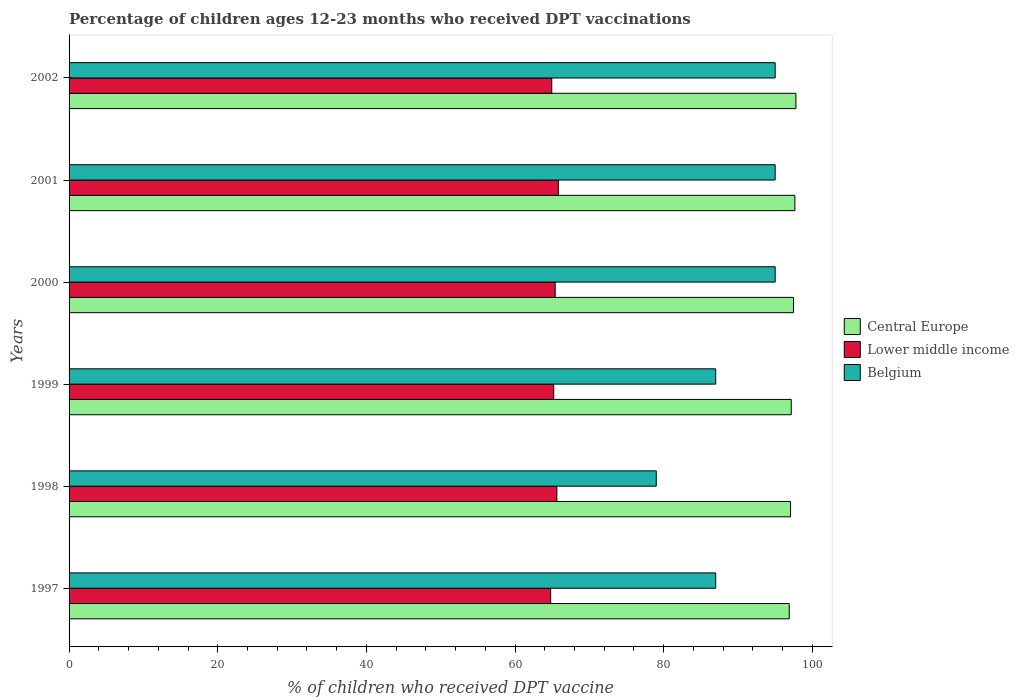How many different coloured bars are there?
Keep it short and to the point. 3. How many groups of bars are there?
Your response must be concise. 6. Are the number of bars per tick equal to the number of legend labels?
Your answer should be compact. Yes. What is the label of the 6th group of bars from the top?
Keep it short and to the point. 1997. What is the percentage of children who received DPT vaccination in Central Europe in 2001?
Your response must be concise. 97.65. Across all years, what is the maximum percentage of children who received DPT vaccination in Central Europe?
Your answer should be compact. 97.79. Across all years, what is the minimum percentage of children who received DPT vaccination in Central Europe?
Your answer should be compact. 96.89. What is the total percentage of children who received DPT vaccination in Lower middle income in the graph?
Give a very brief answer. 391.79. What is the difference between the percentage of children who received DPT vaccination in Belgium in 2000 and that in 2001?
Make the answer very short. 0. What is the difference between the percentage of children who received DPT vaccination in Central Europe in 1998 and the percentage of children who received DPT vaccination in Belgium in 1997?
Make the answer very short. 10.07. What is the average percentage of children who received DPT vaccination in Central Europe per year?
Give a very brief answer. 97.34. In the year 2000, what is the difference between the percentage of children who received DPT vaccination in Central Europe and percentage of children who received DPT vaccination in Lower middle income?
Provide a short and direct response. 32.06. In how many years, is the percentage of children who received DPT vaccination in Belgium greater than 44 %?
Keep it short and to the point. 6. What is the ratio of the percentage of children who received DPT vaccination in Belgium in 1998 to that in 2000?
Your answer should be compact. 0.83. What is the difference between the highest and the second highest percentage of children who received DPT vaccination in Lower middle income?
Provide a short and direct response. 0.19. What is the difference between the highest and the lowest percentage of children who received DPT vaccination in Belgium?
Provide a succinct answer. 16. In how many years, is the percentage of children who received DPT vaccination in Central Europe greater than the average percentage of children who received DPT vaccination in Central Europe taken over all years?
Offer a very short reply. 3. What does the 3rd bar from the top in 1998 represents?
Give a very brief answer. Central Europe. What does the 2nd bar from the bottom in 1997 represents?
Your answer should be compact. Lower middle income. Is it the case that in every year, the sum of the percentage of children who received DPT vaccination in Belgium and percentage of children who received DPT vaccination in Central Europe is greater than the percentage of children who received DPT vaccination in Lower middle income?
Provide a succinct answer. Yes. How many years are there in the graph?
Offer a very short reply. 6. Does the graph contain grids?
Keep it short and to the point. No. Where does the legend appear in the graph?
Keep it short and to the point. Center right. How are the legend labels stacked?
Provide a succinct answer. Vertical. What is the title of the graph?
Your answer should be compact. Percentage of children ages 12-23 months who received DPT vaccinations. What is the label or title of the X-axis?
Offer a very short reply. % of children who received DPT vaccine. What is the % of children who received DPT vaccine in Central Europe in 1997?
Make the answer very short. 96.89. What is the % of children who received DPT vaccine in Lower middle income in 1997?
Keep it short and to the point. 64.79. What is the % of children who received DPT vaccine in Belgium in 1997?
Ensure brevity in your answer.  87. What is the % of children who received DPT vaccine in Central Europe in 1998?
Offer a very short reply. 97.07. What is the % of children who received DPT vaccine of Lower middle income in 1998?
Provide a short and direct response. 65.63. What is the % of children who received DPT vaccine of Belgium in 1998?
Provide a succinct answer. 79. What is the % of children who received DPT vaccine in Central Europe in 1999?
Make the answer very short. 97.16. What is the % of children who received DPT vaccine of Lower middle income in 1999?
Keep it short and to the point. 65.2. What is the % of children who received DPT vaccine of Belgium in 1999?
Keep it short and to the point. 87. What is the % of children who received DPT vaccine in Central Europe in 2000?
Keep it short and to the point. 97.46. What is the % of children who received DPT vaccine of Lower middle income in 2000?
Provide a short and direct response. 65.4. What is the % of children who received DPT vaccine of Belgium in 2000?
Offer a very short reply. 95. What is the % of children who received DPT vaccine of Central Europe in 2001?
Offer a very short reply. 97.65. What is the % of children who received DPT vaccine of Lower middle income in 2001?
Give a very brief answer. 65.82. What is the % of children who received DPT vaccine of Belgium in 2001?
Give a very brief answer. 95. What is the % of children who received DPT vaccine in Central Europe in 2002?
Provide a succinct answer. 97.79. What is the % of children who received DPT vaccine in Lower middle income in 2002?
Keep it short and to the point. 64.94. Across all years, what is the maximum % of children who received DPT vaccine of Central Europe?
Offer a terse response. 97.79. Across all years, what is the maximum % of children who received DPT vaccine in Lower middle income?
Offer a very short reply. 65.82. Across all years, what is the minimum % of children who received DPT vaccine of Central Europe?
Offer a terse response. 96.89. Across all years, what is the minimum % of children who received DPT vaccine in Lower middle income?
Give a very brief answer. 64.79. Across all years, what is the minimum % of children who received DPT vaccine in Belgium?
Give a very brief answer. 79. What is the total % of children who received DPT vaccine of Central Europe in the graph?
Offer a very short reply. 584.03. What is the total % of children who received DPT vaccine in Lower middle income in the graph?
Make the answer very short. 391.79. What is the total % of children who received DPT vaccine in Belgium in the graph?
Give a very brief answer. 538. What is the difference between the % of children who received DPT vaccine in Central Europe in 1997 and that in 1998?
Give a very brief answer. -0.18. What is the difference between the % of children who received DPT vaccine of Lower middle income in 1997 and that in 1998?
Your answer should be very brief. -0.84. What is the difference between the % of children who received DPT vaccine of Belgium in 1997 and that in 1998?
Make the answer very short. 8. What is the difference between the % of children who received DPT vaccine in Central Europe in 1997 and that in 1999?
Offer a very short reply. -0.27. What is the difference between the % of children who received DPT vaccine of Lower middle income in 1997 and that in 1999?
Your response must be concise. -0.41. What is the difference between the % of children who received DPT vaccine in Belgium in 1997 and that in 1999?
Your response must be concise. 0. What is the difference between the % of children who received DPT vaccine in Central Europe in 1997 and that in 2000?
Your answer should be compact. -0.57. What is the difference between the % of children who received DPT vaccine in Lower middle income in 1997 and that in 2000?
Your answer should be compact. -0.61. What is the difference between the % of children who received DPT vaccine of Central Europe in 1997 and that in 2001?
Your response must be concise. -0.76. What is the difference between the % of children who received DPT vaccine in Lower middle income in 1997 and that in 2001?
Keep it short and to the point. -1.03. What is the difference between the % of children who received DPT vaccine of Central Europe in 1997 and that in 2002?
Your answer should be very brief. -0.9. What is the difference between the % of children who received DPT vaccine of Lower middle income in 1997 and that in 2002?
Your answer should be compact. -0.15. What is the difference between the % of children who received DPT vaccine in Belgium in 1997 and that in 2002?
Provide a succinct answer. -8. What is the difference between the % of children who received DPT vaccine of Central Europe in 1998 and that in 1999?
Make the answer very short. -0.1. What is the difference between the % of children who received DPT vaccine in Lower middle income in 1998 and that in 1999?
Ensure brevity in your answer.  0.43. What is the difference between the % of children who received DPT vaccine of Belgium in 1998 and that in 1999?
Give a very brief answer. -8. What is the difference between the % of children who received DPT vaccine in Central Europe in 1998 and that in 2000?
Keep it short and to the point. -0.39. What is the difference between the % of children who received DPT vaccine in Lower middle income in 1998 and that in 2000?
Give a very brief answer. 0.23. What is the difference between the % of children who received DPT vaccine in Belgium in 1998 and that in 2000?
Your answer should be very brief. -16. What is the difference between the % of children who received DPT vaccine in Central Europe in 1998 and that in 2001?
Provide a succinct answer. -0.58. What is the difference between the % of children who received DPT vaccine in Lower middle income in 1998 and that in 2001?
Your response must be concise. -0.19. What is the difference between the % of children who received DPT vaccine of Belgium in 1998 and that in 2001?
Your response must be concise. -16. What is the difference between the % of children who received DPT vaccine in Central Europe in 1998 and that in 2002?
Give a very brief answer. -0.72. What is the difference between the % of children who received DPT vaccine in Lower middle income in 1998 and that in 2002?
Offer a very short reply. 0.69. What is the difference between the % of children who received DPT vaccine in Belgium in 1998 and that in 2002?
Provide a short and direct response. -16. What is the difference between the % of children who received DPT vaccine in Central Europe in 1999 and that in 2000?
Offer a terse response. -0.3. What is the difference between the % of children who received DPT vaccine in Lower middle income in 1999 and that in 2000?
Provide a short and direct response. -0.2. What is the difference between the % of children who received DPT vaccine of Belgium in 1999 and that in 2000?
Offer a very short reply. -8. What is the difference between the % of children who received DPT vaccine of Central Europe in 1999 and that in 2001?
Your answer should be very brief. -0.49. What is the difference between the % of children who received DPT vaccine in Lower middle income in 1999 and that in 2001?
Keep it short and to the point. -0.62. What is the difference between the % of children who received DPT vaccine of Belgium in 1999 and that in 2001?
Give a very brief answer. -8. What is the difference between the % of children who received DPT vaccine in Central Europe in 1999 and that in 2002?
Your answer should be very brief. -0.63. What is the difference between the % of children who received DPT vaccine in Lower middle income in 1999 and that in 2002?
Ensure brevity in your answer.  0.26. What is the difference between the % of children who received DPT vaccine in Belgium in 1999 and that in 2002?
Offer a very short reply. -8. What is the difference between the % of children who received DPT vaccine in Central Europe in 2000 and that in 2001?
Offer a very short reply. -0.19. What is the difference between the % of children who received DPT vaccine in Lower middle income in 2000 and that in 2001?
Keep it short and to the point. -0.42. What is the difference between the % of children who received DPT vaccine in Central Europe in 2000 and that in 2002?
Your answer should be very brief. -0.33. What is the difference between the % of children who received DPT vaccine of Lower middle income in 2000 and that in 2002?
Your answer should be very brief. 0.46. What is the difference between the % of children who received DPT vaccine of Belgium in 2000 and that in 2002?
Your answer should be very brief. 0. What is the difference between the % of children who received DPT vaccine of Central Europe in 2001 and that in 2002?
Provide a short and direct response. -0.14. What is the difference between the % of children who received DPT vaccine of Lower middle income in 2001 and that in 2002?
Offer a very short reply. 0.88. What is the difference between the % of children who received DPT vaccine of Belgium in 2001 and that in 2002?
Make the answer very short. 0. What is the difference between the % of children who received DPT vaccine in Central Europe in 1997 and the % of children who received DPT vaccine in Lower middle income in 1998?
Your answer should be very brief. 31.26. What is the difference between the % of children who received DPT vaccine in Central Europe in 1997 and the % of children who received DPT vaccine in Belgium in 1998?
Provide a succinct answer. 17.89. What is the difference between the % of children who received DPT vaccine in Lower middle income in 1997 and the % of children who received DPT vaccine in Belgium in 1998?
Your response must be concise. -14.21. What is the difference between the % of children who received DPT vaccine of Central Europe in 1997 and the % of children who received DPT vaccine of Lower middle income in 1999?
Give a very brief answer. 31.69. What is the difference between the % of children who received DPT vaccine in Central Europe in 1997 and the % of children who received DPT vaccine in Belgium in 1999?
Make the answer very short. 9.89. What is the difference between the % of children who received DPT vaccine in Lower middle income in 1997 and the % of children who received DPT vaccine in Belgium in 1999?
Keep it short and to the point. -22.21. What is the difference between the % of children who received DPT vaccine of Central Europe in 1997 and the % of children who received DPT vaccine of Lower middle income in 2000?
Offer a very short reply. 31.49. What is the difference between the % of children who received DPT vaccine in Central Europe in 1997 and the % of children who received DPT vaccine in Belgium in 2000?
Ensure brevity in your answer.  1.89. What is the difference between the % of children who received DPT vaccine of Lower middle income in 1997 and the % of children who received DPT vaccine of Belgium in 2000?
Provide a short and direct response. -30.21. What is the difference between the % of children who received DPT vaccine of Central Europe in 1997 and the % of children who received DPT vaccine of Lower middle income in 2001?
Give a very brief answer. 31.07. What is the difference between the % of children who received DPT vaccine of Central Europe in 1997 and the % of children who received DPT vaccine of Belgium in 2001?
Offer a terse response. 1.89. What is the difference between the % of children who received DPT vaccine of Lower middle income in 1997 and the % of children who received DPT vaccine of Belgium in 2001?
Offer a very short reply. -30.21. What is the difference between the % of children who received DPT vaccine of Central Europe in 1997 and the % of children who received DPT vaccine of Lower middle income in 2002?
Provide a succinct answer. 31.95. What is the difference between the % of children who received DPT vaccine in Central Europe in 1997 and the % of children who received DPT vaccine in Belgium in 2002?
Provide a succinct answer. 1.89. What is the difference between the % of children who received DPT vaccine in Lower middle income in 1997 and the % of children who received DPT vaccine in Belgium in 2002?
Your answer should be compact. -30.21. What is the difference between the % of children who received DPT vaccine in Central Europe in 1998 and the % of children who received DPT vaccine in Lower middle income in 1999?
Give a very brief answer. 31.86. What is the difference between the % of children who received DPT vaccine of Central Europe in 1998 and the % of children who received DPT vaccine of Belgium in 1999?
Give a very brief answer. 10.07. What is the difference between the % of children who received DPT vaccine of Lower middle income in 1998 and the % of children who received DPT vaccine of Belgium in 1999?
Offer a terse response. -21.37. What is the difference between the % of children who received DPT vaccine in Central Europe in 1998 and the % of children who received DPT vaccine in Lower middle income in 2000?
Keep it short and to the point. 31.67. What is the difference between the % of children who received DPT vaccine in Central Europe in 1998 and the % of children who received DPT vaccine in Belgium in 2000?
Provide a short and direct response. 2.07. What is the difference between the % of children who received DPT vaccine of Lower middle income in 1998 and the % of children who received DPT vaccine of Belgium in 2000?
Ensure brevity in your answer.  -29.37. What is the difference between the % of children who received DPT vaccine in Central Europe in 1998 and the % of children who received DPT vaccine in Lower middle income in 2001?
Keep it short and to the point. 31.25. What is the difference between the % of children who received DPT vaccine of Central Europe in 1998 and the % of children who received DPT vaccine of Belgium in 2001?
Your answer should be compact. 2.07. What is the difference between the % of children who received DPT vaccine in Lower middle income in 1998 and the % of children who received DPT vaccine in Belgium in 2001?
Provide a short and direct response. -29.37. What is the difference between the % of children who received DPT vaccine of Central Europe in 1998 and the % of children who received DPT vaccine of Lower middle income in 2002?
Your response must be concise. 32.13. What is the difference between the % of children who received DPT vaccine of Central Europe in 1998 and the % of children who received DPT vaccine of Belgium in 2002?
Provide a short and direct response. 2.07. What is the difference between the % of children who received DPT vaccine of Lower middle income in 1998 and the % of children who received DPT vaccine of Belgium in 2002?
Your answer should be compact. -29.37. What is the difference between the % of children who received DPT vaccine of Central Europe in 1999 and the % of children who received DPT vaccine of Lower middle income in 2000?
Offer a very short reply. 31.76. What is the difference between the % of children who received DPT vaccine in Central Europe in 1999 and the % of children who received DPT vaccine in Belgium in 2000?
Keep it short and to the point. 2.16. What is the difference between the % of children who received DPT vaccine of Lower middle income in 1999 and the % of children who received DPT vaccine of Belgium in 2000?
Ensure brevity in your answer.  -29.8. What is the difference between the % of children who received DPT vaccine of Central Europe in 1999 and the % of children who received DPT vaccine of Lower middle income in 2001?
Ensure brevity in your answer.  31.34. What is the difference between the % of children who received DPT vaccine in Central Europe in 1999 and the % of children who received DPT vaccine in Belgium in 2001?
Make the answer very short. 2.16. What is the difference between the % of children who received DPT vaccine of Lower middle income in 1999 and the % of children who received DPT vaccine of Belgium in 2001?
Ensure brevity in your answer.  -29.8. What is the difference between the % of children who received DPT vaccine of Central Europe in 1999 and the % of children who received DPT vaccine of Lower middle income in 2002?
Keep it short and to the point. 32.22. What is the difference between the % of children who received DPT vaccine of Central Europe in 1999 and the % of children who received DPT vaccine of Belgium in 2002?
Give a very brief answer. 2.16. What is the difference between the % of children who received DPT vaccine of Lower middle income in 1999 and the % of children who received DPT vaccine of Belgium in 2002?
Provide a succinct answer. -29.8. What is the difference between the % of children who received DPT vaccine in Central Europe in 2000 and the % of children who received DPT vaccine in Lower middle income in 2001?
Your answer should be compact. 31.64. What is the difference between the % of children who received DPT vaccine in Central Europe in 2000 and the % of children who received DPT vaccine in Belgium in 2001?
Offer a very short reply. 2.46. What is the difference between the % of children who received DPT vaccine in Lower middle income in 2000 and the % of children who received DPT vaccine in Belgium in 2001?
Your answer should be very brief. -29.6. What is the difference between the % of children who received DPT vaccine in Central Europe in 2000 and the % of children who received DPT vaccine in Lower middle income in 2002?
Give a very brief answer. 32.52. What is the difference between the % of children who received DPT vaccine in Central Europe in 2000 and the % of children who received DPT vaccine in Belgium in 2002?
Offer a very short reply. 2.46. What is the difference between the % of children who received DPT vaccine of Lower middle income in 2000 and the % of children who received DPT vaccine of Belgium in 2002?
Provide a short and direct response. -29.6. What is the difference between the % of children who received DPT vaccine of Central Europe in 2001 and the % of children who received DPT vaccine of Lower middle income in 2002?
Keep it short and to the point. 32.71. What is the difference between the % of children who received DPT vaccine in Central Europe in 2001 and the % of children who received DPT vaccine in Belgium in 2002?
Offer a terse response. 2.65. What is the difference between the % of children who received DPT vaccine of Lower middle income in 2001 and the % of children who received DPT vaccine of Belgium in 2002?
Offer a terse response. -29.18. What is the average % of children who received DPT vaccine in Central Europe per year?
Make the answer very short. 97.34. What is the average % of children who received DPT vaccine of Lower middle income per year?
Keep it short and to the point. 65.3. What is the average % of children who received DPT vaccine in Belgium per year?
Provide a succinct answer. 89.67. In the year 1997, what is the difference between the % of children who received DPT vaccine in Central Europe and % of children who received DPT vaccine in Lower middle income?
Your answer should be compact. 32.1. In the year 1997, what is the difference between the % of children who received DPT vaccine of Central Europe and % of children who received DPT vaccine of Belgium?
Your answer should be very brief. 9.89. In the year 1997, what is the difference between the % of children who received DPT vaccine in Lower middle income and % of children who received DPT vaccine in Belgium?
Offer a very short reply. -22.21. In the year 1998, what is the difference between the % of children who received DPT vaccine of Central Europe and % of children who received DPT vaccine of Lower middle income?
Provide a short and direct response. 31.44. In the year 1998, what is the difference between the % of children who received DPT vaccine in Central Europe and % of children who received DPT vaccine in Belgium?
Provide a succinct answer. 18.07. In the year 1998, what is the difference between the % of children who received DPT vaccine of Lower middle income and % of children who received DPT vaccine of Belgium?
Offer a terse response. -13.37. In the year 1999, what is the difference between the % of children who received DPT vaccine of Central Europe and % of children who received DPT vaccine of Lower middle income?
Give a very brief answer. 31.96. In the year 1999, what is the difference between the % of children who received DPT vaccine of Central Europe and % of children who received DPT vaccine of Belgium?
Give a very brief answer. 10.16. In the year 1999, what is the difference between the % of children who received DPT vaccine in Lower middle income and % of children who received DPT vaccine in Belgium?
Provide a short and direct response. -21.8. In the year 2000, what is the difference between the % of children who received DPT vaccine of Central Europe and % of children who received DPT vaccine of Lower middle income?
Provide a short and direct response. 32.06. In the year 2000, what is the difference between the % of children who received DPT vaccine of Central Europe and % of children who received DPT vaccine of Belgium?
Provide a short and direct response. 2.46. In the year 2000, what is the difference between the % of children who received DPT vaccine of Lower middle income and % of children who received DPT vaccine of Belgium?
Your answer should be compact. -29.6. In the year 2001, what is the difference between the % of children who received DPT vaccine of Central Europe and % of children who received DPT vaccine of Lower middle income?
Offer a very short reply. 31.83. In the year 2001, what is the difference between the % of children who received DPT vaccine in Central Europe and % of children who received DPT vaccine in Belgium?
Provide a short and direct response. 2.65. In the year 2001, what is the difference between the % of children who received DPT vaccine in Lower middle income and % of children who received DPT vaccine in Belgium?
Your response must be concise. -29.18. In the year 2002, what is the difference between the % of children who received DPT vaccine of Central Europe and % of children who received DPT vaccine of Lower middle income?
Your answer should be very brief. 32.85. In the year 2002, what is the difference between the % of children who received DPT vaccine in Central Europe and % of children who received DPT vaccine in Belgium?
Make the answer very short. 2.79. In the year 2002, what is the difference between the % of children who received DPT vaccine in Lower middle income and % of children who received DPT vaccine in Belgium?
Make the answer very short. -30.06. What is the ratio of the % of children who received DPT vaccine in Lower middle income in 1997 to that in 1998?
Offer a very short reply. 0.99. What is the ratio of the % of children who received DPT vaccine in Belgium in 1997 to that in 1998?
Provide a succinct answer. 1.1. What is the ratio of the % of children who received DPT vaccine of Central Europe in 1997 to that in 1999?
Ensure brevity in your answer.  1. What is the ratio of the % of children who received DPT vaccine of Lower middle income in 1997 to that in 1999?
Keep it short and to the point. 0.99. What is the ratio of the % of children who received DPT vaccine in Belgium in 1997 to that in 1999?
Your answer should be compact. 1. What is the ratio of the % of children who received DPT vaccine in Central Europe in 1997 to that in 2000?
Your answer should be very brief. 0.99. What is the ratio of the % of children who received DPT vaccine of Belgium in 1997 to that in 2000?
Make the answer very short. 0.92. What is the ratio of the % of children who received DPT vaccine in Lower middle income in 1997 to that in 2001?
Your answer should be very brief. 0.98. What is the ratio of the % of children who received DPT vaccine of Belgium in 1997 to that in 2001?
Provide a short and direct response. 0.92. What is the ratio of the % of children who received DPT vaccine in Lower middle income in 1997 to that in 2002?
Make the answer very short. 1. What is the ratio of the % of children who received DPT vaccine of Belgium in 1997 to that in 2002?
Offer a terse response. 0.92. What is the ratio of the % of children who received DPT vaccine in Lower middle income in 1998 to that in 1999?
Keep it short and to the point. 1.01. What is the ratio of the % of children who received DPT vaccine in Belgium in 1998 to that in 1999?
Your answer should be compact. 0.91. What is the ratio of the % of children who received DPT vaccine of Lower middle income in 1998 to that in 2000?
Give a very brief answer. 1. What is the ratio of the % of children who received DPT vaccine of Belgium in 1998 to that in 2000?
Provide a succinct answer. 0.83. What is the ratio of the % of children who received DPT vaccine in Belgium in 1998 to that in 2001?
Your response must be concise. 0.83. What is the ratio of the % of children who received DPT vaccine of Central Europe in 1998 to that in 2002?
Keep it short and to the point. 0.99. What is the ratio of the % of children who received DPT vaccine in Lower middle income in 1998 to that in 2002?
Keep it short and to the point. 1.01. What is the ratio of the % of children who received DPT vaccine in Belgium in 1998 to that in 2002?
Offer a very short reply. 0.83. What is the ratio of the % of children who received DPT vaccine of Central Europe in 1999 to that in 2000?
Provide a short and direct response. 1. What is the ratio of the % of children who received DPT vaccine in Belgium in 1999 to that in 2000?
Give a very brief answer. 0.92. What is the ratio of the % of children who received DPT vaccine in Central Europe in 1999 to that in 2001?
Provide a short and direct response. 0.99. What is the ratio of the % of children who received DPT vaccine in Lower middle income in 1999 to that in 2001?
Keep it short and to the point. 0.99. What is the ratio of the % of children who received DPT vaccine of Belgium in 1999 to that in 2001?
Your response must be concise. 0.92. What is the ratio of the % of children who received DPT vaccine of Belgium in 1999 to that in 2002?
Keep it short and to the point. 0.92. What is the ratio of the % of children who received DPT vaccine in Central Europe in 2000 to that in 2001?
Ensure brevity in your answer.  1. What is the ratio of the % of children who received DPT vaccine of Lower middle income in 2000 to that in 2001?
Provide a short and direct response. 0.99. What is the ratio of the % of children who received DPT vaccine in Belgium in 2000 to that in 2001?
Give a very brief answer. 1. What is the ratio of the % of children who received DPT vaccine in Lower middle income in 2000 to that in 2002?
Offer a very short reply. 1.01. What is the ratio of the % of children who received DPT vaccine in Belgium in 2000 to that in 2002?
Offer a terse response. 1. What is the ratio of the % of children who received DPT vaccine in Lower middle income in 2001 to that in 2002?
Ensure brevity in your answer.  1.01. What is the ratio of the % of children who received DPT vaccine in Belgium in 2001 to that in 2002?
Give a very brief answer. 1. What is the difference between the highest and the second highest % of children who received DPT vaccine of Central Europe?
Keep it short and to the point. 0.14. What is the difference between the highest and the second highest % of children who received DPT vaccine of Lower middle income?
Your answer should be compact. 0.19. What is the difference between the highest and the lowest % of children who received DPT vaccine in Central Europe?
Give a very brief answer. 0.9. What is the difference between the highest and the lowest % of children who received DPT vaccine in Lower middle income?
Provide a short and direct response. 1.03. What is the difference between the highest and the lowest % of children who received DPT vaccine in Belgium?
Your answer should be very brief. 16. 